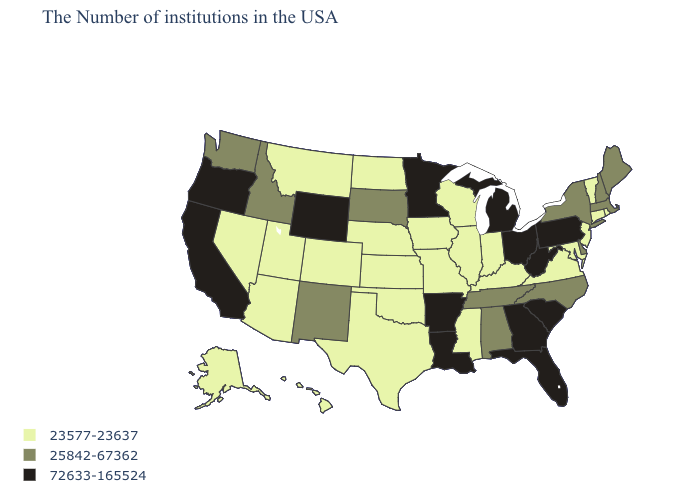Name the states that have a value in the range 25842-67362?
Be succinct. Maine, Massachusetts, New Hampshire, New York, Delaware, North Carolina, Alabama, Tennessee, South Dakota, New Mexico, Idaho, Washington. What is the highest value in the West ?
Write a very short answer. 72633-165524. Does California have the lowest value in the USA?
Keep it brief. No. Which states hav the highest value in the MidWest?
Short answer required. Ohio, Michigan, Minnesota. What is the value of Tennessee?
Concise answer only. 25842-67362. What is the value of Illinois?
Concise answer only. 23577-23637. Name the states that have a value in the range 25842-67362?
Short answer required. Maine, Massachusetts, New Hampshire, New York, Delaware, North Carolina, Alabama, Tennessee, South Dakota, New Mexico, Idaho, Washington. Among the states that border Alabama , which have the highest value?
Concise answer only. Florida, Georgia. What is the highest value in the South ?
Quick response, please. 72633-165524. What is the value of Montana?
Short answer required. 23577-23637. Which states hav the highest value in the South?
Be succinct. South Carolina, West Virginia, Florida, Georgia, Louisiana, Arkansas. Name the states that have a value in the range 72633-165524?
Give a very brief answer. Pennsylvania, South Carolina, West Virginia, Ohio, Florida, Georgia, Michigan, Louisiana, Arkansas, Minnesota, Wyoming, California, Oregon. Does Massachusetts have the same value as California?
Concise answer only. No. Does Pennsylvania have the highest value in the Northeast?
Write a very short answer. Yes. What is the lowest value in the Northeast?
Answer briefly. 23577-23637. 